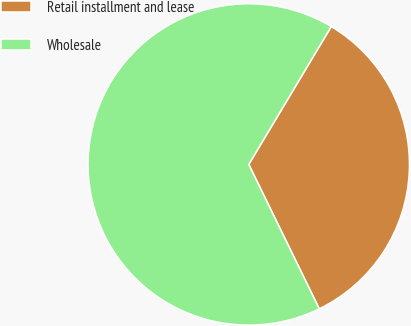Convert chart to OTSL. <chart><loc_0><loc_0><loc_500><loc_500><pie_chart><fcel>Retail installment and lease<fcel>Wholesale<nl><fcel>34.19%<fcel>65.81%<nl></chart> 